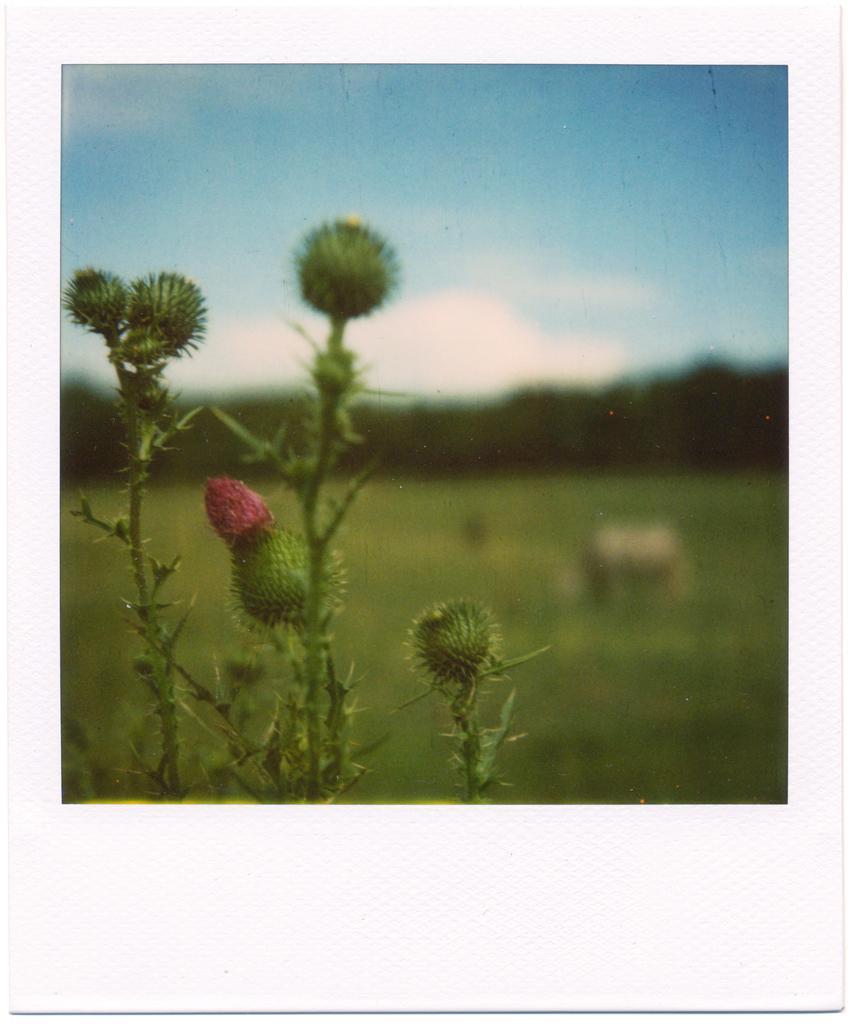In one or two sentences, can you explain what this image depicts? This is the zoom-in picture of a plant were we can see stem and fruit. 